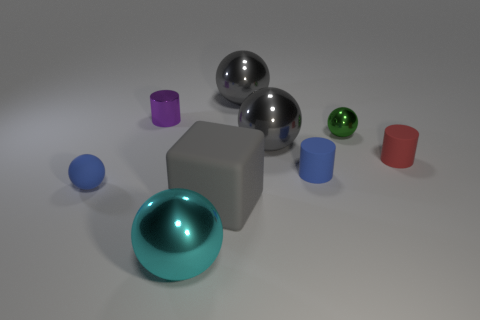Which objects stand out the most in this arrangement and why? The objects that stand out the most are the shiny silver spheres due to their reflective surfaces and central positioning, which naturally draw the viewer's attention amidst the matte textures of the other items. 